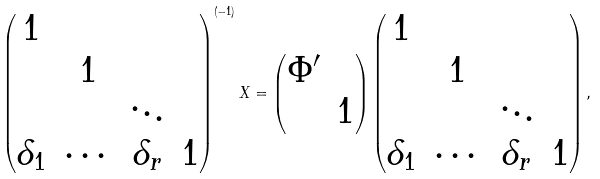<formula> <loc_0><loc_0><loc_500><loc_500>\begin{pmatrix} 1 & & & \\ & 1 & & \\ & & \ddots & \\ \delta _ { 1 } & \cdots & \delta _ { r } & 1 \\ \end{pmatrix} ^ { ( - 1 ) } X = \begin{pmatrix} \Phi ^ { \prime } & \\ & 1 \\ \end{pmatrix} \begin{pmatrix} 1 & & & \\ & 1 & & \\ & & \ddots & \\ \delta _ { 1 } & \cdots & \delta _ { r } & 1 \\ \end{pmatrix} ,</formula> 